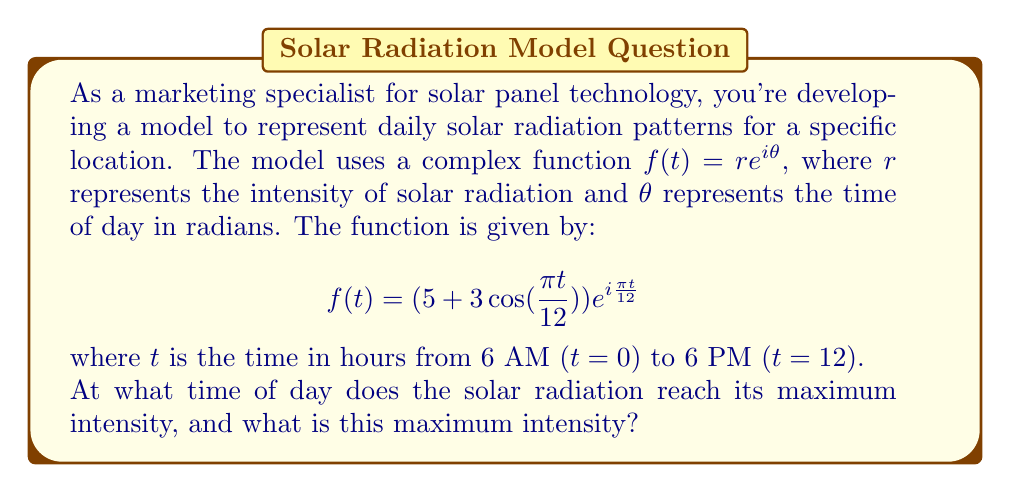Provide a solution to this math problem. To solve this problem, we need to follow these steps:

1) The intensity of solar radiation is represented by the modulus of the complex function $|f(t)|$. In polar form, this is simply the $r$ value:

   $$|f(t)| = 5 + 3\cos(\frac{\pi t}{12})$$

2) To find the maximum intensity, we need to find the maximum value of this function. We can do this by differentiating and setting the derivative to zero:

   $$\frac{d}{dt}|f(t)| = -\frac{\pi}{4}\sin(\frac{\pi t}{12})$$

3) Setting this to zero:

   $$-\frac{\pi}{4}\sin(\frac{\pi t}{12}) = 0$$

   $$\sin(\frac{\pi t}{12}) = 0$$

4) This occurs when $\frac{\pi t}{12} = 0, \pi, 2\pi, ...$

   The solution in our time range (0 to 12) is $t = 0$ or $t = 12$.

5) To determine which of these gives the maximum (rather than minimum), we can check the second derivative or simply evaluate $|f(t)|$ at these points:

   At $t = 0$ or $t = 12$: $|f(t)| = 5 + 3 = 8$
   At $t = 6$: $|f(t)| = 5 - 3 = 2$

6) Therefore, the maximum occurs at $t = 0$ or $t = 12$, which correspond to 6 AM and 6 PM. Given that this is a model for solar radiation, it makes more sense for the maximum to occur at 6 PM.

7) The maximum intensity is 8 units.
Answer: The solar radiation reaches its maximum intensity at 6 PM (t = 12), and the maximum intensity is 8 units. 